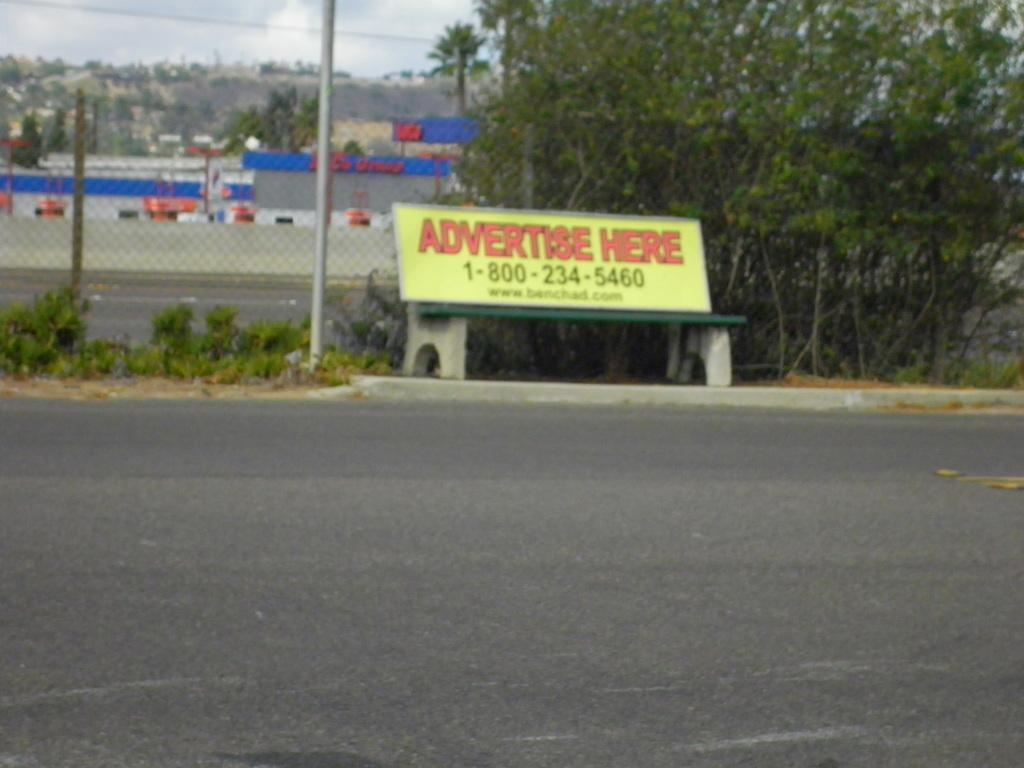What is the main object in the center of the image? There is a bench in the center of the image. What is written or displayed on the ground near the bench? There is some text and numbers placed on the ground near the bench. What can be seen in the background of the image? There is a fence, a building, a group of trees, and the sky visible in the background of the image. What type of team is playing on the seashore in the image? There is no seashore or team present in the image; it features a bench, text and numbers on the ground, and various background elements. 